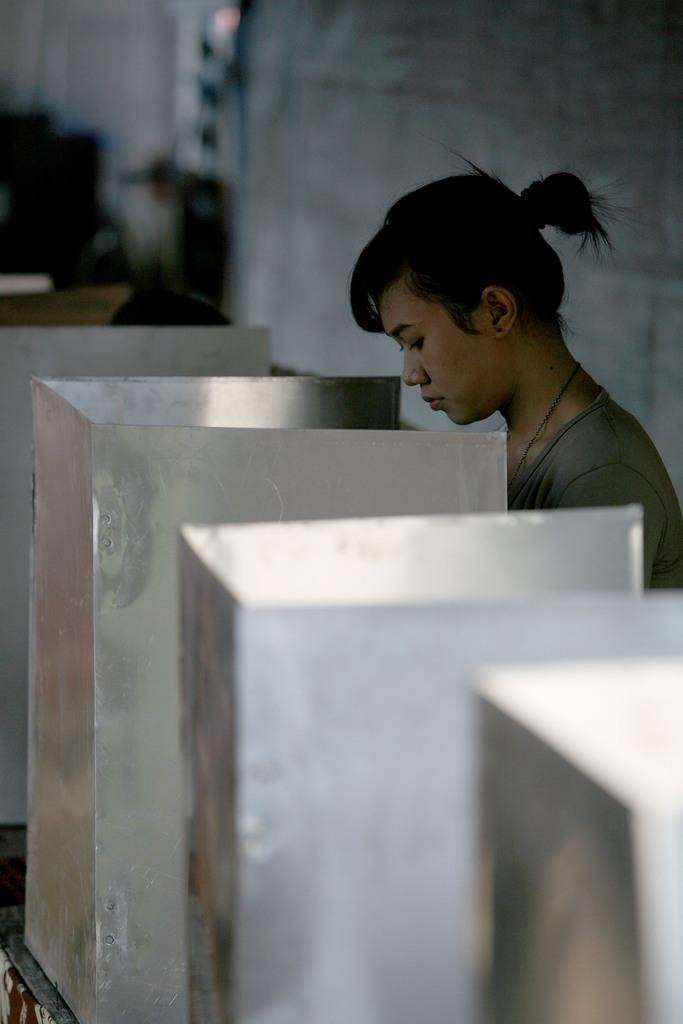What is the main subject of the image? There is a person in the image. What can be seen in front of the person? There are steel objects in front of the person. What is located behind the person? There is a wall behind the person. Can you describe the objects that are not clearly visible in the image? There are blurred objects in the image. What type of basketball is being blown by the person in the image? There is no basketball or blowing action present in the image. 